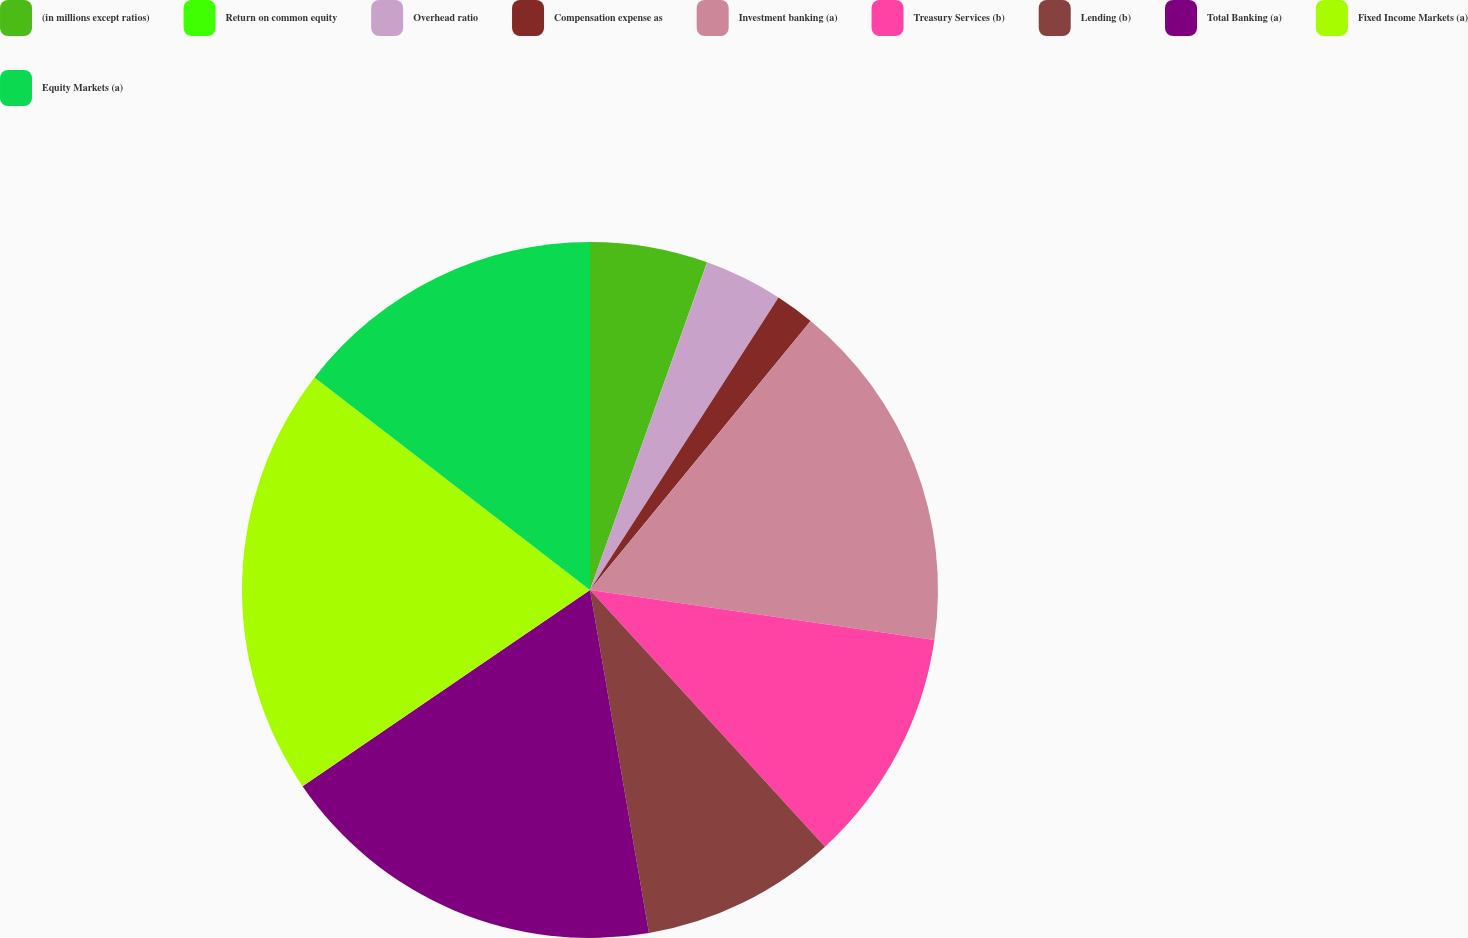Convert chart. <chart><loc_0><loc_0><loc_500><loc_500><pie_chart><fcel>(in millions except ratios)<fcel>Return on common equity<fcel>Overhead ratio<fcel>Compensation expense as<fcel>Investment banking (a)<fcel>Treasury Services (b)<fcel>Lending (b)<fcel>Total Banking (a)<fcel>Fixed Income Markets (a)<fcel>Equity Markets (a)<nl><fcel>5.46%<fcel>0.01%<fcel>3.64%<fcel>1.82%<fcel>16.36%<fcel>10.91%<fcel>9.09%<fcel>18.18%<fcel>19.99%<fcel>14.54%<nl></chart> 